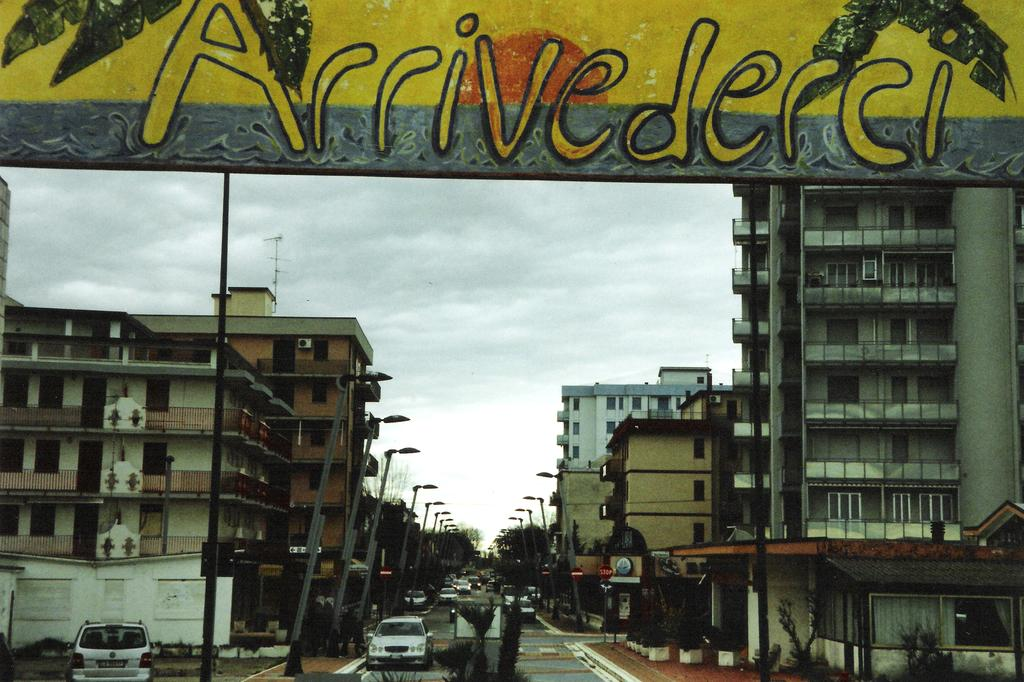What can be seen on the road in the image? There are vehicles on the road in the image. What objects are present in the image that are not vehicles? There are poles, lights, boards, buildings, trees, and the sky visible in the image. Can you describe the buildings in the image? The buildings in the image are part of the urban landscape. What type of vegetation is present in the image? There are trees in the image. What color is the paint on the smile in the image? There is no paint or smile present in the image. 